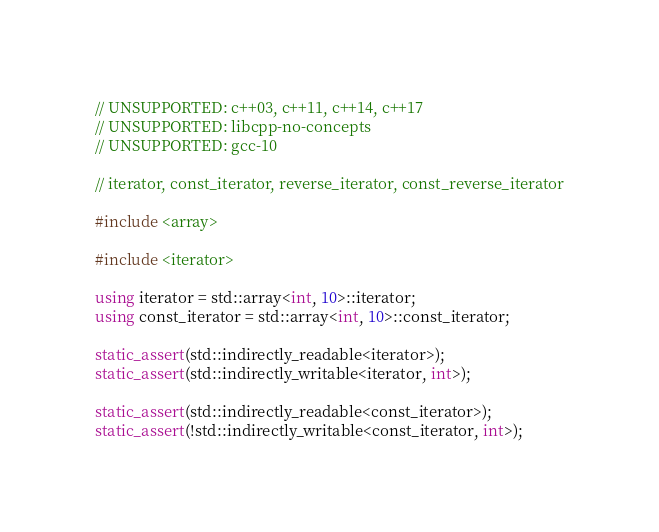<code> <loc_0><loc_0><loc_500><loc_500><_C++_>
// UNSUPPORTED: c++03, c++11, c++14, c++17
// UNSUPPORTED: libcpp-no-concepts
// UNSUPPORTED: gcc-10

// iterator, const_iterator, reverse_iterator, const_reverse_iterator

#include <array>

#include <iterator>

using iterator = std::array<int, 10>::iterator;
using const_iterator = std::array<int, 10>::const_iterator;

static_assert(std::indirectly_readable<iterator>);
static_assert(std::indirectly_writable<iterator, int>);

static_assert(std::indirectly_readable<const_iterator>);
static_assert(!std::indirectly_writable<const_iterator, int>);
</code> 